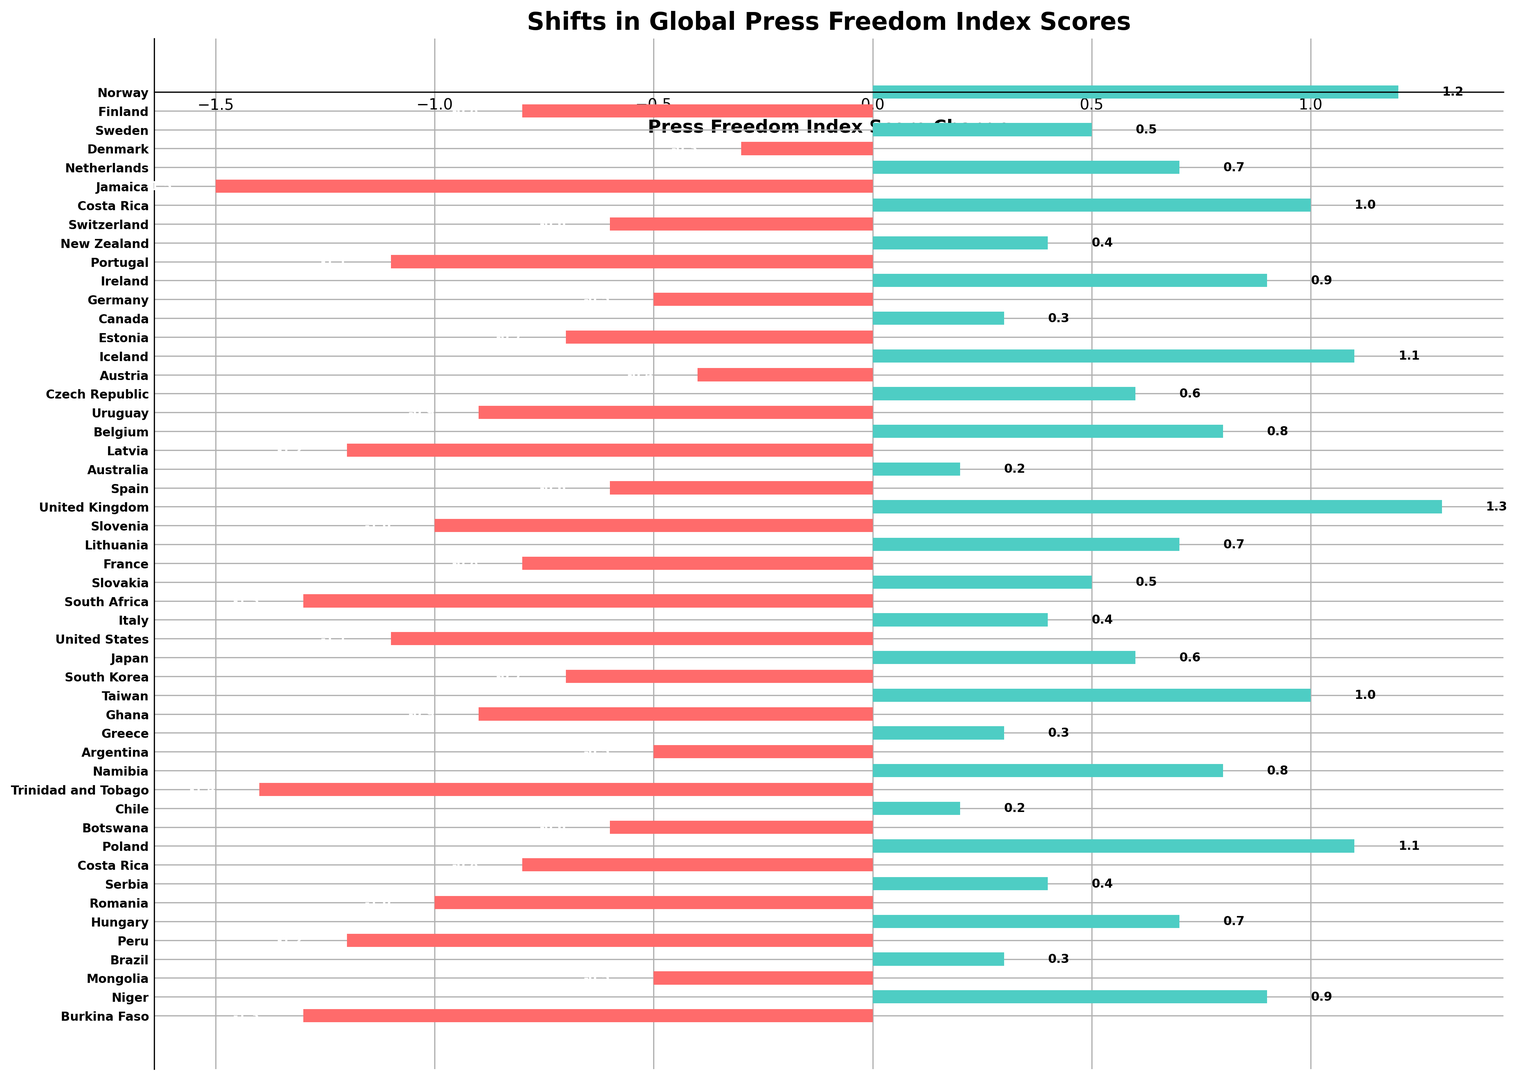How many countries have shown a positive change in the Press Freedom Index Score? Count the number of bars/entries that are green (indicating positive change)
Answer: 22 Which country has the highest positive change in the Press Freedom Index Score? Identify the longest green bar. The label corresponding to the longest green bar is the country with the highest positive change.
Answer: United Kingdom What is the combined change in the Press Freedom Index Score for Norway, Iceland, and Portugal? Identify the scores for Norway (1.2), Iceland (1.1), and Portugal (-1.1), and then add them: \(1.2 + 1.1 - 1.1 = 1.2\)
Answer: 1.2 Which country has the lowest negative change in the Press Freedom Index Score? Identify the longest red bar. The label corresponding to the longest red bar is the country with the highest negative change.
Answer: Jamaica How many countries have shown a negative change greater than -1? Count the number of red bars that have a value greater than -1 (only including bars between 0 and -1)
Answer: 13 What is the average negative change in the Press Freedom Index Score for countries with a negative score? Identify all the negative values, sum them up, then divide by the number of negative values: \(\frac{-0.8 + -0.3 + -1.5 + -0.6 + -0.5 + -0.7 + -1.3 + -1.1 + -0.6 + -1.0 + -1.2 + -1.0 + -1.3 + -1.4}{14}\approx -0.85\)
Answer: -0.85 Which country directly follows Belgium in terms of positive change in the Press Freedom Index Score? Locate Belgium and find the next country in the list.
Answer: Latvia Compare the Press Freedom Index Score change of Finland and France. Which is greater? Identify the scores for Finland (-0.8) and France (-0.8) and compare them. Since both values are equal
Answer: They are equal Which country has a press freedom score change depicted by the second shortest green bar? Identify the second shortest green bar and find the corresponding country.
Answer: Chile 